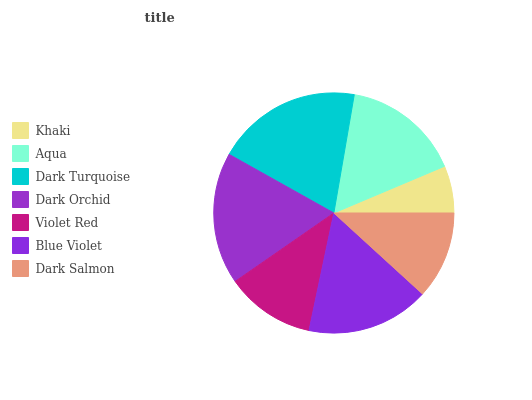Is Khaki the minimum?
Answer yes or no. Yes. Is Dark Turquoise the maximum?
Answer yes or no. Yes. Is Aqua the minimum?
Answer yes or no. No. Is Aqua the maximum?
Answer yes or no. No. Is Aqua greater than Khaki?
Answer yes or no. Yes. Is Khaki less than Aqua?
Answer yes or no. Yes. Is Khaki greater than Aqua?
Answer yes or no. No. Is Aqua less than Khaki?
Answer yes or no. No. Is Aqua the high median?
Answer yes or no. Yes. Is Aqua the low median?
Answer yes or no. Yes. Is Dark Salmon the high median?
Answer yes or no. No. Is Dark Turquoise the low median?
Answer yes or no. No. 